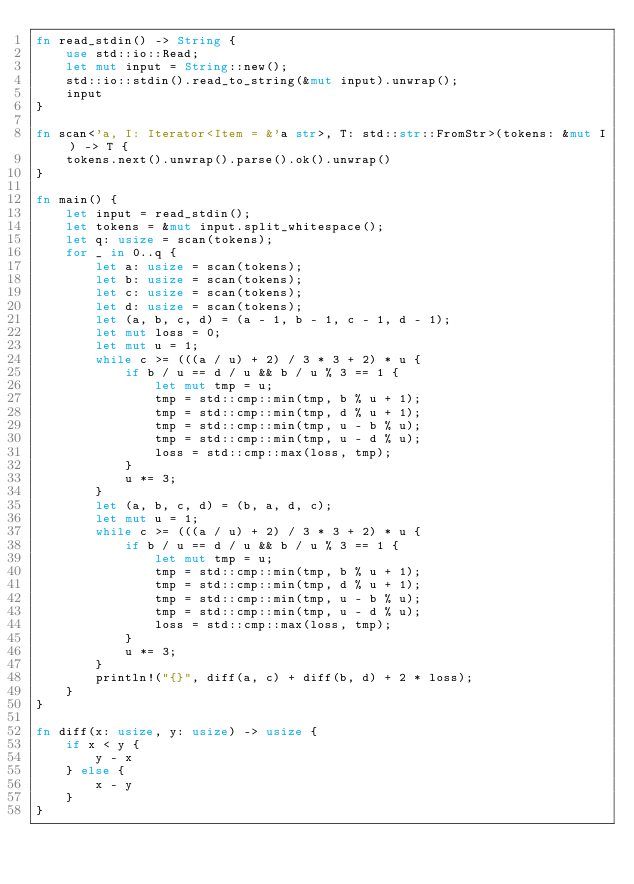<code> <loc_0><loc_0><loc_500><loc_500><_Rust_>fn read_stdin() -> String {
    use std::io::Read;
    let mut input = String::new();
    std::io::stdin().read_to_string(&mut input).unwrap();
    input
}

fn scan<'a, I: Iterator<Item = &'a str>, T: std::str::FromStr>(tokens: &mut I) -> T {
    tokens.next().unwrap().parse().ok().unwrap()
}

fn main() {
    let input = read_stdin();
    let tokens = &mut input.split_whitespace();
    let q: usize = scan(tokens);
    for _ in 0..q {
        let a: usize = scan(tokens);
        let b: usize = scan(tokens);
        let c: usize = scan(tokens);
        let d: usize = scan(tokens);
        let (a, b, c, d) = (a - 1, b - 1, c - 1, d - 1);
        let mut loss = 0;
        let mut u = 1;
        while c >= (((a / u) + 2) / 3 * 3 + 2) * u {
            if b / u == d / u && b / u % 3 == 1 {
                let mut tmp = u;
                tmp = std::cmp::min(tmp, b % u + 1);
                tmp = std::cmp::min(tmp, d % u + 1);
                tmp = std::cmp::min(tmp, u - b % u);
                tmp = std::cmp::min(tmp, u - d % u);
                loss = std::cmp::max(loss, tmp);
            }
            u *= 3;
        }
        let (a, b, c, d) = (b, a, d, c);
        let mut u = 1;
        while c >= (((a / u) + 2) / 3 * 3 + 2) * u {
            if b / u == d / u && b / u % 3 == 1 {
                let mut tmp = u;
                tmp = std::cmp::min(tmp, b % u + 1);
                tmp = std::cmp::min(tmp, d % u + 1);
                tmp = std::cmp::min(tmp, u - b % u);
                tmp = std::cmp::min(tmp, u - d % u);
                loss = std::cmp::max(loss, tmp);
            }
            u *= 3;
        }
        println!("{}", diff(a, c) + diff(b, d) + 2 * loss);
    }
}

fn diff(x: usize, y: usize) -> usize {
    if x < y {
        y - x
    } else {
        x - y
    }
}
</code> 